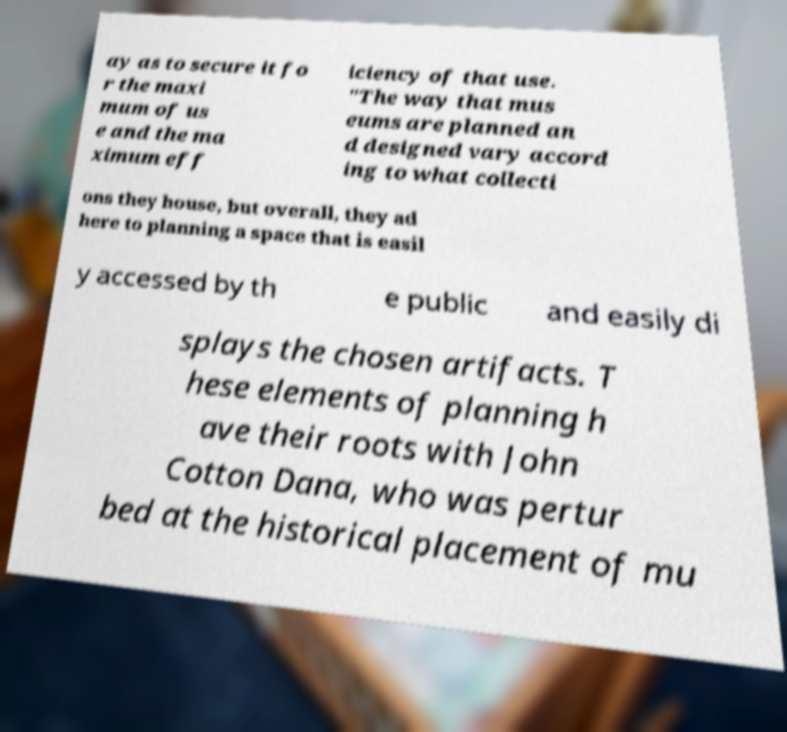Can you read and provide the text displayed in the image?This photo seems to have some interesting text. Can you extract and type it out for me? ay as to secure it fo r the maxi mum of us e and the ma ximum eff iciency of that use. "The way that mus eums are planned an d designed vary accord ing to what collecti ons they house, but overall, they ad here to planning a space that is easil y accessed by th e public and easily di splays the chosen artifacts. T hese elements of planning h ave their roots with John Cotton Dana, who was pertur bed at the historical placement of mu 